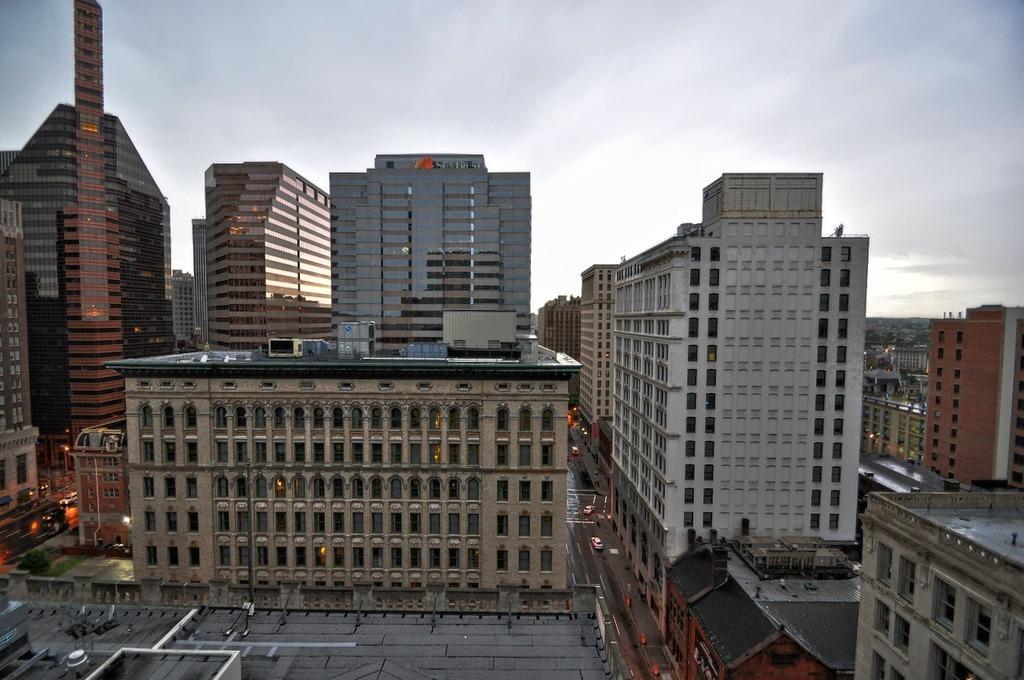Can you describe this image briefly? In this image there are buildings and skyscrapers. There are roads in the image. There are vehicles moving on the road. At the top there is the sky. 